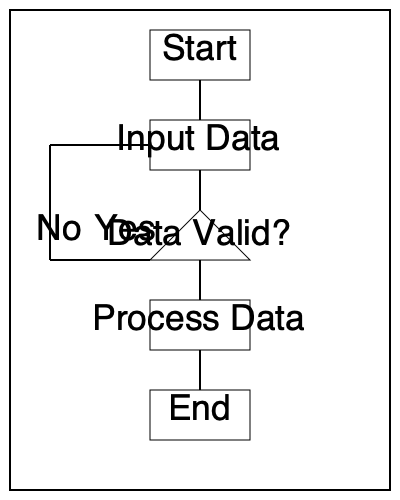In the given flowchart, what happens if the data is not valid? To answer this question, we need to follow the flow of the chart step by step:

1. The process starts at the "Start" box.
2. It then moves to the "Input Data" box.
3. After inputting data, we reach a decision diamond asking "Data Valid?"
4. There are two possible paths from this decision:
   a. If the answer is "Yes", the flow goes downward to "Process Data".
   b. If the answer is "No", the flow goes to the left.
5. Following the "No" path, we can see that:
   a. The line goes left from the decision diamond.
   b. It then goes upward.
   c. Finally, it connects back to the line leading into the "Input Data" box.

This path creates a loop. When the data is not valid, instead of proceeding to process the data, the flow returns to the "Input Data" step. This indicates that the system will ask for input again if the initial input was invalid.
Answer: The flow returns to the "Input Data" step. 